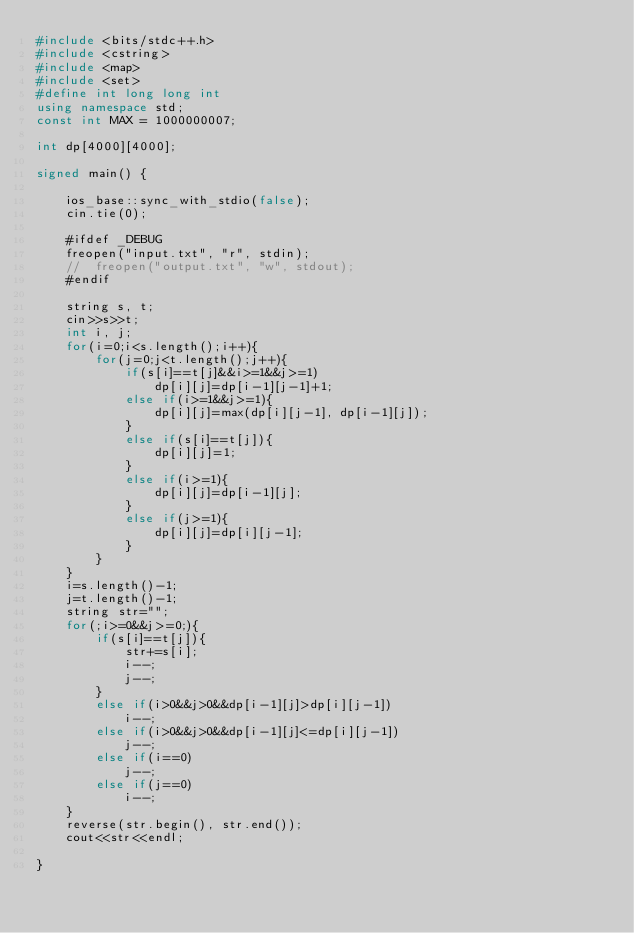Convert code to text. <code><loc_0><loc_0><loc_500><loc_500><_C++_>#include <bits/stdc++.h>
#include <cstring>
#include <map>
#include <set>
#define int long long int
using namespace std;
const int MAX = 1000000007;

int dp[4000][4000];

signed main() {
 
    ios_base::sync_with_stdio(false);
    cin.tie(0);
    
    #ifdef _DEBUG
    freopen("input.txt", "r", stdin);
    //  freopen("output.txt", "w", stdout);
    #endif
    
    string s, t;
    cin>>s>>t;
    int i, j;
    for(i=0;i<s.length();i++){
        for(j=0;j<t.length();j++){
            if(s[i]==t[j]&&i>=1&&j>=1)
                dp[i][j]=dp[i-1][j-1]+1;
            else if(i>=1&&j>=1){
                dp[i][j]=max(dp[i][j-1], dp[i-1][j]);
            }
            else if(s[i]==t[j]){
                dp[i][j]=1;
            }
            else if(i>=1){
                dp[i][j]=dp[i-1][j];
            }
            else if(j>=1){
                dp[i][j]=dp[i][j-1];
            }
        }
    }
    i=s.length()-1;
    j=t.length()-1;
    string str="";
    for(;i>=0&&j>=0;){
        if(s[i]==t[j]){
            str+=s[i];
            i--;
            j--;
        }
        else if(i>0&&j>0&&dp[i-1][j]>dp[i][j-1])
            i--;
        else if(i>0&&j>0&&dp[i-1][j]<=dp[i][j-1])
            j--;
        else if(i==0)
            j--;
        else if(j==0)
            i--;
    }
    reverse(str.begin(), str.end());
    cout<<str<<endl;
    
}
</code> 